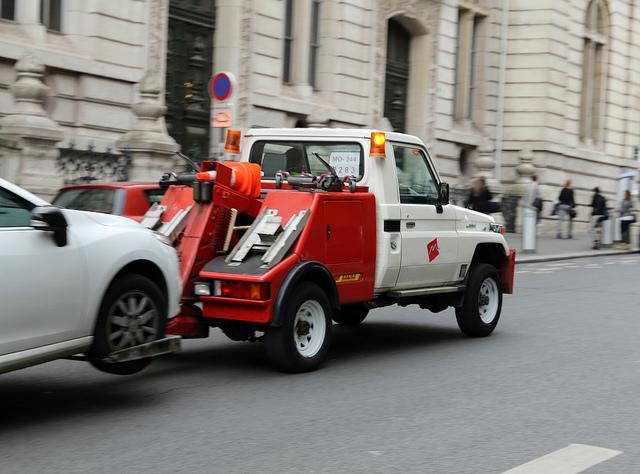What type of truck is being pictured in this image? tow truck 